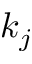Convert formula to latex. <formula><loc_0><loc_0><loc_500><loc_500>k _ { j }</formula> 